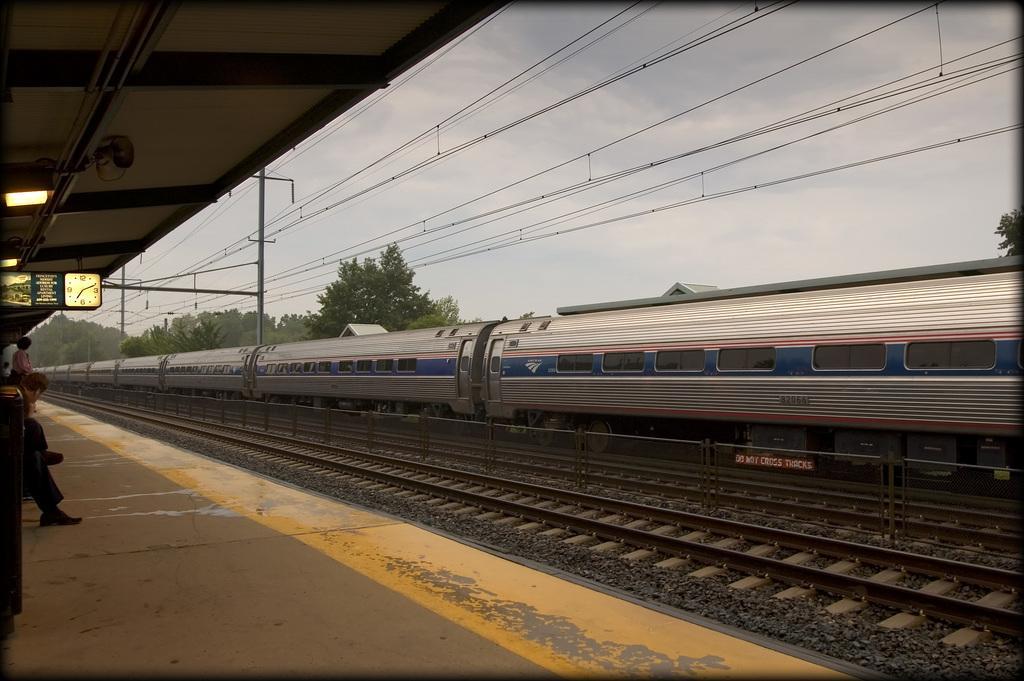Can you describe this image briefly? In this picture we can see a train on the track, beside the train we can see few trees and poles, on the left side of the image we can see few people, lights and a digital board, in the background we can see cables and clouds. 